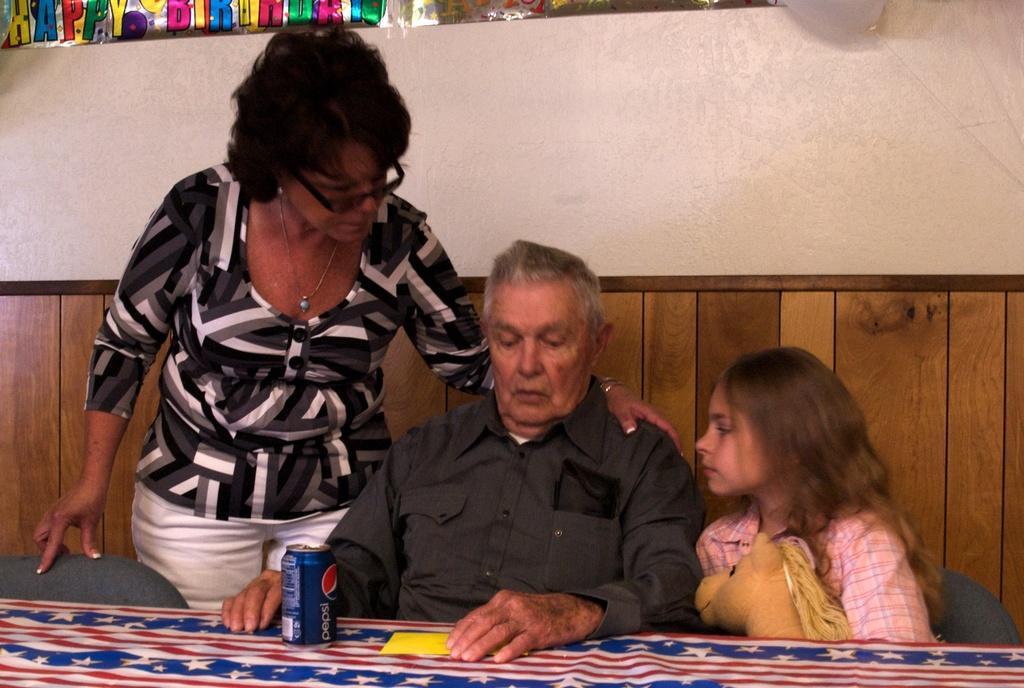How would you summarize this image in a sentence or two? In this image in the front there is a table and on the table there is tin and there is a paper. In the center there are persons sitting and there is a woman standing and in the background there is a wall and on the top there is some text visible and there is a balloon which is white in colour and there is an empty chair in the center. 